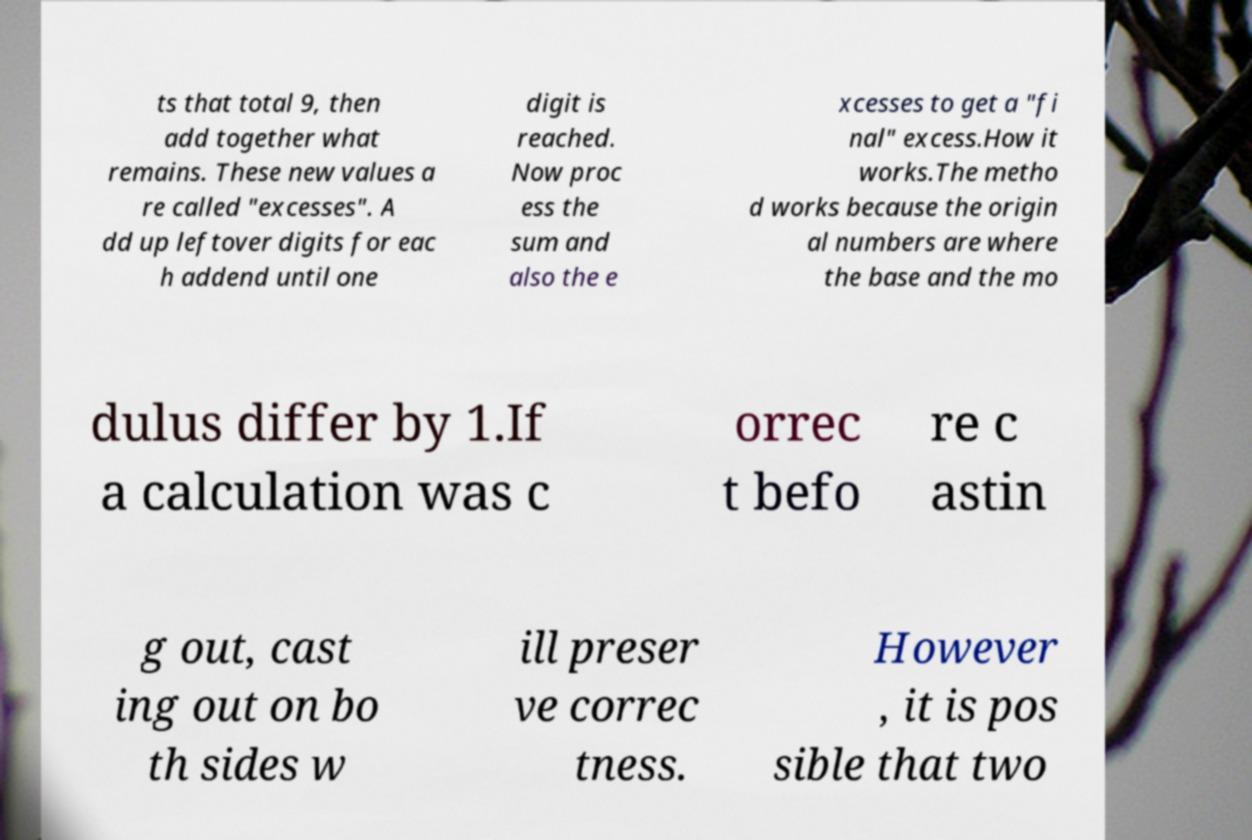For documentation purposes, I need the text within this image transcribed. Could you provide that? ts that total 9, then add together what remains. These new values a re called "excesses". A dd up leftover digits for eac h addend until one digit is reached. Now proc ess the sum and also the e xcesses to get a "fi nal" excess.How it works.The metho d works because the origin al numbers are where the base and the mo dulus differ by 1.If a calculation was c orrec t befo re c astin g out, cast ing out on bo th sides w ill preser ve correc tness. However , it is pos sible that two 